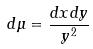<formula> <loc_0><loc_0><loc_500><loc_500>d \mu = \frac { d x d y } { y ^ { 2 } }</formula> 